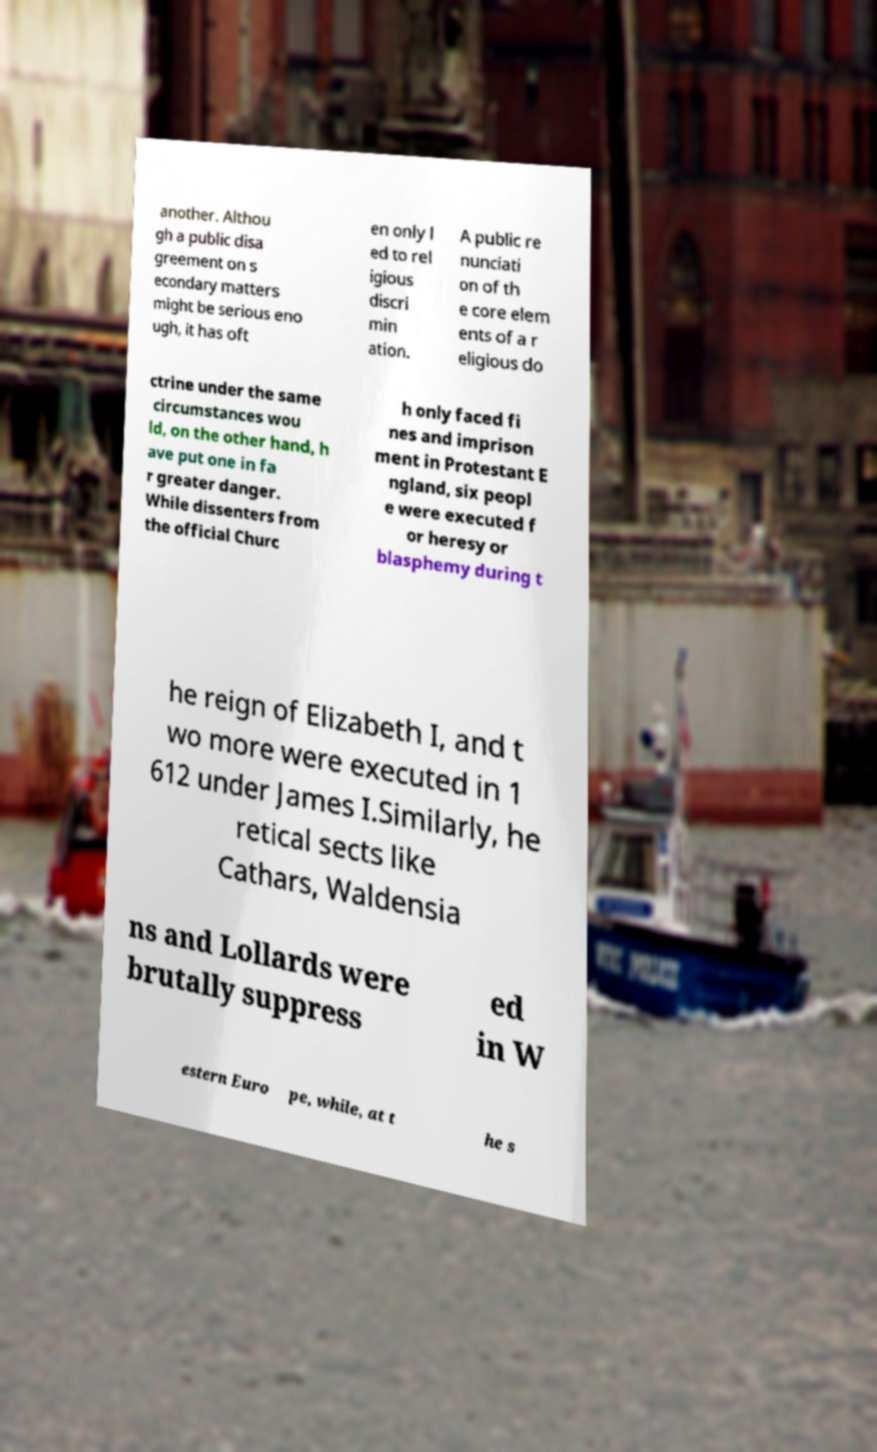I need the written content from this picture converted into text. Can you do that? another. Althou gh a public disa greement on s econdary matters might be serious eno ugh, it has oft en only l ed to rel igious discri min ation. A public re nunciati on of th e core elem ents of a r eligious do ctrine under the same circumstances wou ld, on the other hand, h ave put one in fa r greater danger. While dissenters from the official Churc h only faced fi nes and imprison ment in Protestant E ngland, six peopl e were executed f or heresy or blasphemy during t he reign of Elizabeth I, and t wo more were executed in 1 612 under James I.Similarly, he retical sects like Cathars, Waldensia ns and Lollards were brutally suppress ed in W estern Euro pe, while, at t he s 